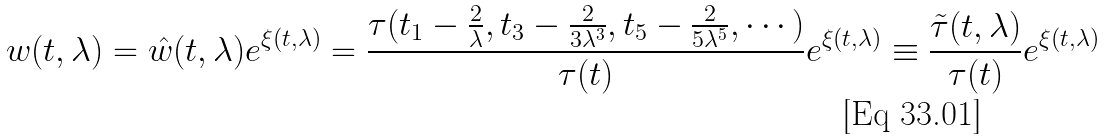<formula> <loc_0><loc_0><loc_500><loc_500>w ( t , \lambda ) = \hat { w } ( t , \lambda ) e ^ { \xi ( t , \lambda ) } = \frac { \tau ( t _ { 1 } - \frac { 2 } { \lambda } , t _ { 3 } - \frac { 2 } { 3 \lambda ^ { 3 } } , t _ { 5 } - \frac { 2 } { 5 \lambda ^ { 5 } } , \cdots ) } { \tau ( t ) } e ^ { \xi ( t , \lambda ) } \equiv \frac { \tilde { \tau } ( t , \lambda ) } { \tau ( t ) } e ^ { \xi ( t , \lambda ) }</formula> 